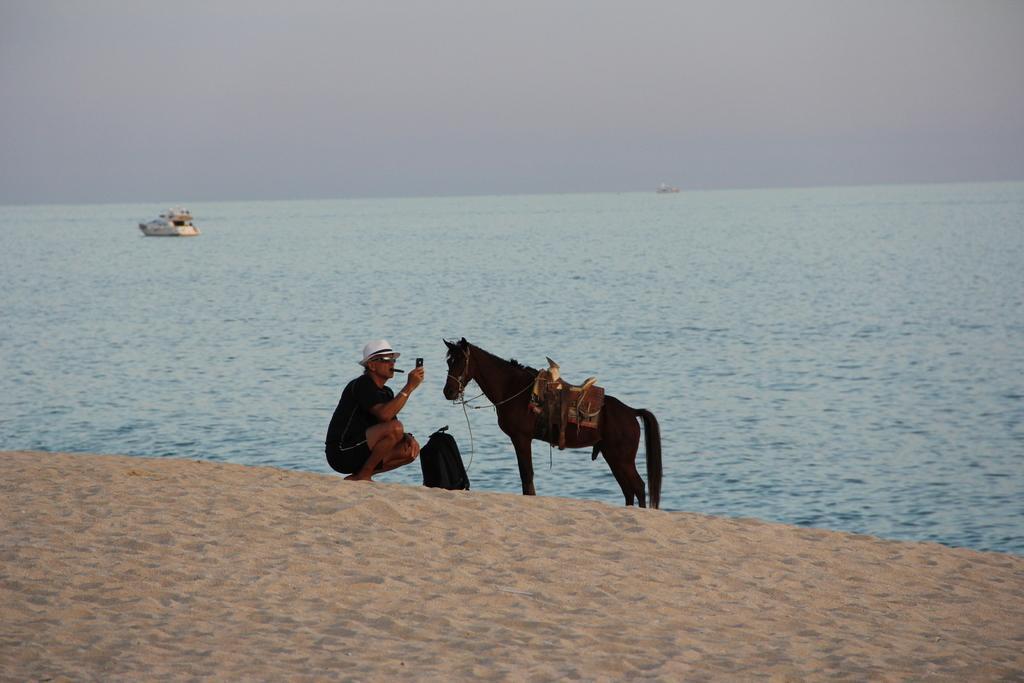Could you give a brief overview of what you see in this image? In this picture, we can see a person holding an object is smoking, and we can see horse, ground with sand, a bag, water, boats, and the sky. 